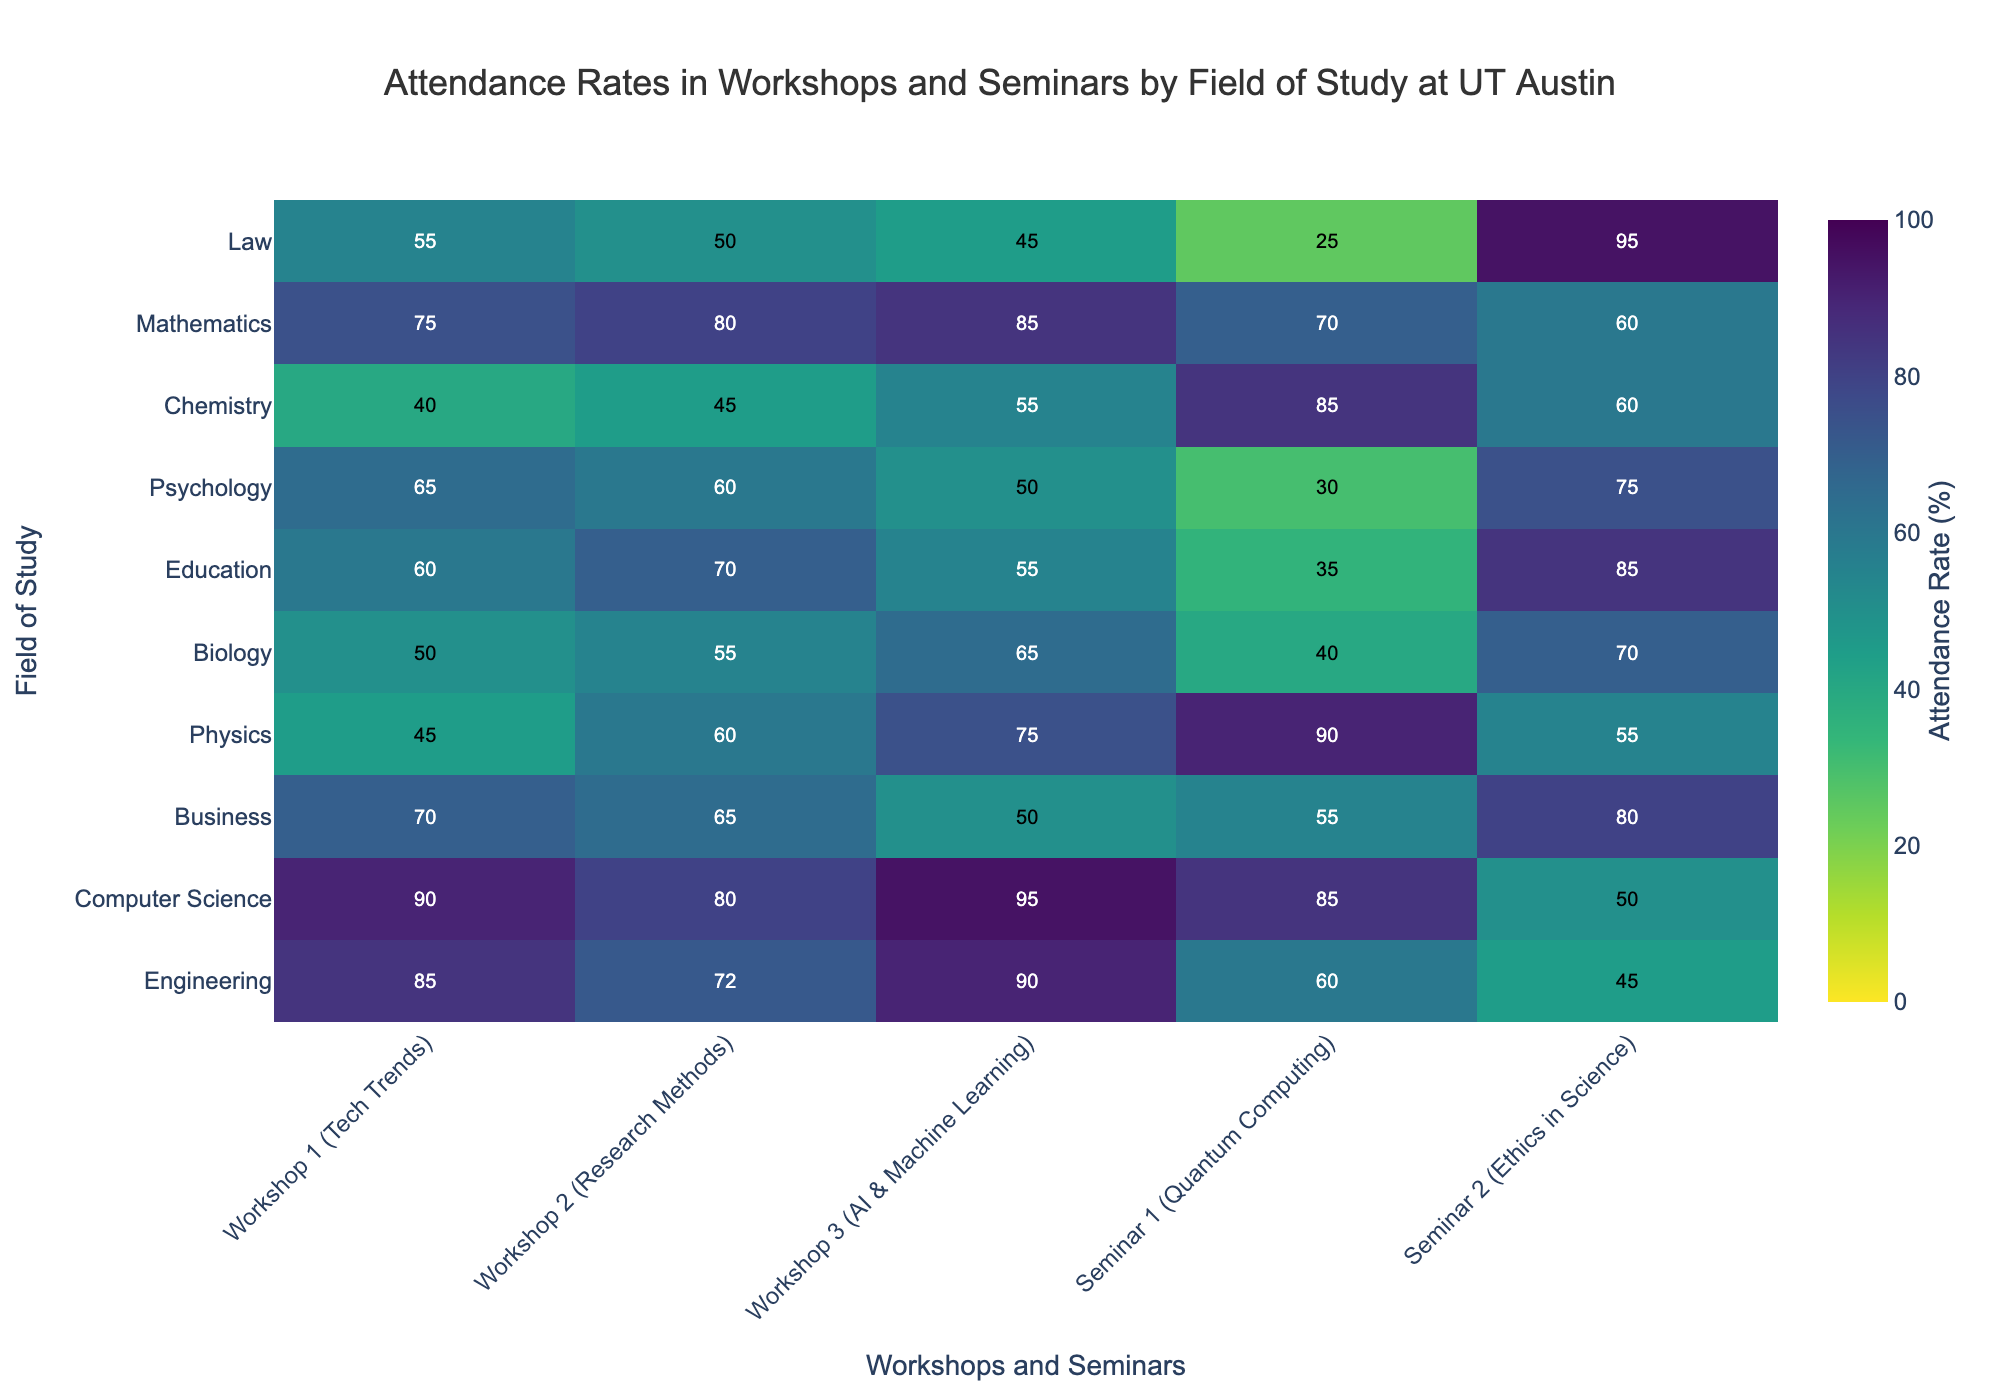What's the highest attendance rate for a workshop or seminar? To find the highest attendance rate, look for the cell with the highest value in the heatmap. The value is 95 in Workshop 3 (AI & Machine Learning) for Computer Science students.
Answer: 95 Which field of study has the lowest overall attendance across all events? To determine this, sum the attendance rates for each field of study and compare them. Chemistry has the lowest sum with (40+45+55+85+60) = 285.
Answer: Chemistry In which workshop does Business have the highest attendance rate? By examining the Business row, it's clear that Workshop 1 (Tech Trends) has the highest attendance rate of 70.
Answer: Workshop 1 (Tech Trends) How does the attendance rate for Seminar 2 (Ethics in Science) compare between Law and Education? Comparing the values in the final column for Law (95) and Education (85), Law has a higher attendance rate by 10.
Answer: Law>Education What is the average attendance rate for Computer Science across all events? Sum the values for Computer Science (90, 80, 95, 85, 50), and then divide by the number of events (5): The average is (90+80+95+85+50)/5 = 80.
Answer: 80 Which event has the lowest attendance rate in Physics? By looking at the Physics row, Seminar 1 (Quantum Computing) has the lowest attendance rate of 45.
Answer: Seminar 1 (Quantum Computing) What is the total attendance rate for workshops 1, 2, and 3 for Engineering students? Add the rates for Engineering in Workshops 1, 2, and 3: (85 + 72 + 90) = 247.
Answer: 247 How does the attendance rate for Mathematics in Seminar 1 compare to that in Seminar 2? For Mathematics, Seminar 1 has an attendance rate of 70, while Seminar 2 has 60. Thus, Seminar 1 has a higher attendance by 10.
Answer: Seminar 1>Seminar 2 What is the median attendance rate for Education across all events? Organize the attendance rates for Education (60, 70, 55, 35, 85), in ascending order (35, 55, 60, 70, 85), and find the middle value, which is 60.
Answer: 60 Which workshop or seminar has the lowest attendance rate across all fields of study? The lowest attendance rate can be found by looking for the smallest cell value in the heatmap, which is 25 for Seminar 1 (Quantum Computing) in the Law field.
Answer: Seminar 1 (Quantum Computing) 